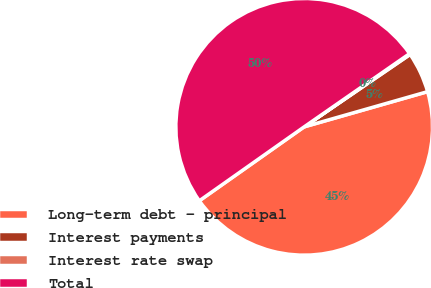Convert chart. <chart><loc_0><loc_0><loc_500><loc_500><pie_chart><fcel>Long-term debt - principal<fcel>Interest payments<fcel>Interest rate swap<fcel>Total<nl><fcel>44.65%<fcel>5.12%<fcel>0.12%<fcel>50.12%<nl></chart> 